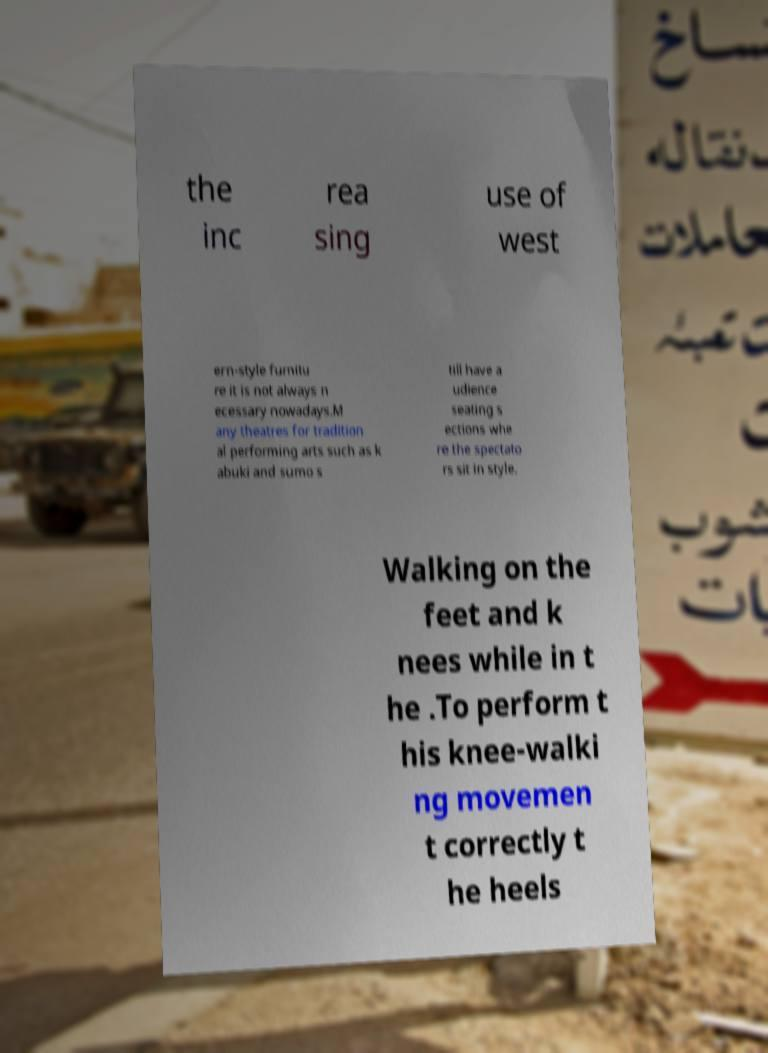What messages or text are displayed in this image? I need them in a readable, typed format. the inc rea sing use of west ern-style furnitu re it is not always n ecessary nowadays.M any theatres for tradition al performing arts such as k abuki and sumo s till have a udience seating s ections whe re the spectato rs sit in style. Walking on the feet and k nees while in t he .To perform t his knee-walki ng movemen t correctly t he heels 